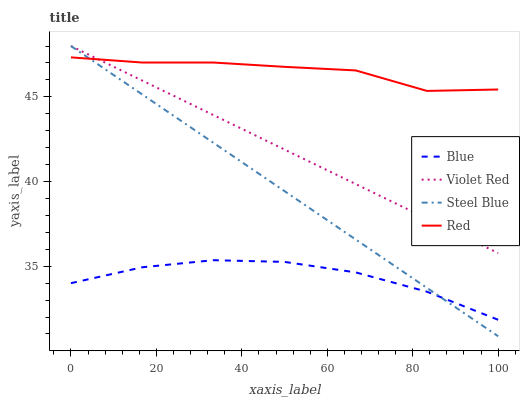Does Blue have the minimum area under the curve?
Answer yes or no. Yes. Does Red have the maximum area under the curve?
Answer yes or no. Yes. Does Violet Red have the minimum area under the curve?
Answer yes or no. No. Does Violet Red have the maximum area under the curve?
Answer yes or no. No. Is Steel Blue the smoothest?
Answer yes or no. Yes. Is Red the roughest?
Answer yes or no. Yes. Is Violet Red the smoothest?
Answer yes or no. No. Is Violet Red the roughest?
Answer yes or no. No. Does Violet Red have the lowest value?
Answer yes or no. No. Does Steel Blue have the highest value?
Answer yes or no. Yes. Does Red have the highest value?
Answer yes or no. No. Is Blue less than Violet Red?
Answer yes or no. Yes. Is Violet Red greater than Blue?
Answer yes or no. Yes. Does Steel Blue intersect Blue?
Answer yes or no. Yes. Is Steel Blue less than Blue?
Answer yes or no. No. Is Steel Blue greater than Blue?
Answer yes or no. No. Does Blue intersect Violet Red?
Answer yes or no. No. 